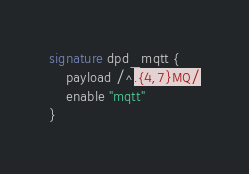<code> <loc_0><loc_0><loc_500><loc_500><_SML_>
signature dpd_mqtt {
	payload /^.{4,7}MQ/
	enable "mqtt"
}
</code> 